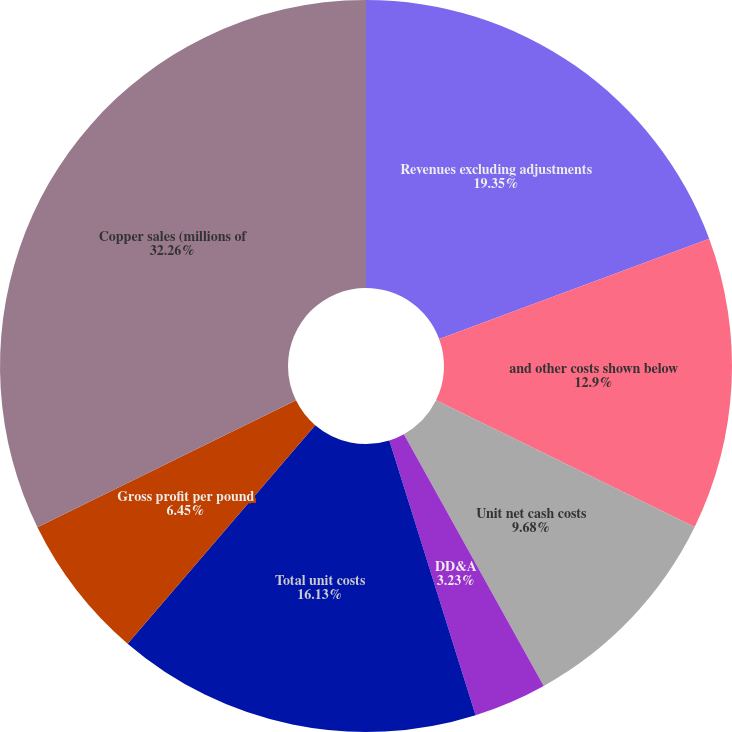Convert chart. <chart><loc_0><loc_0><loc_500><loc_500><pie_chart><fcel>Revenues excluding adjustments<fcel>and other costs shown below<fcel>Unit net cash costs<fcel>DD&A<fcel>Noncash and other costs net<fcel>Total unit costs<fcel>Gross profit per pound<fcel>Copper sales (millions of<nl><fcel>19.35%<fcel>12.9%<fcel>9.68%<fcel>3.23%<fcel>0.0%<fcel>16.13%<fcel>6.45%<fcel>32.26%<nl></chart> 